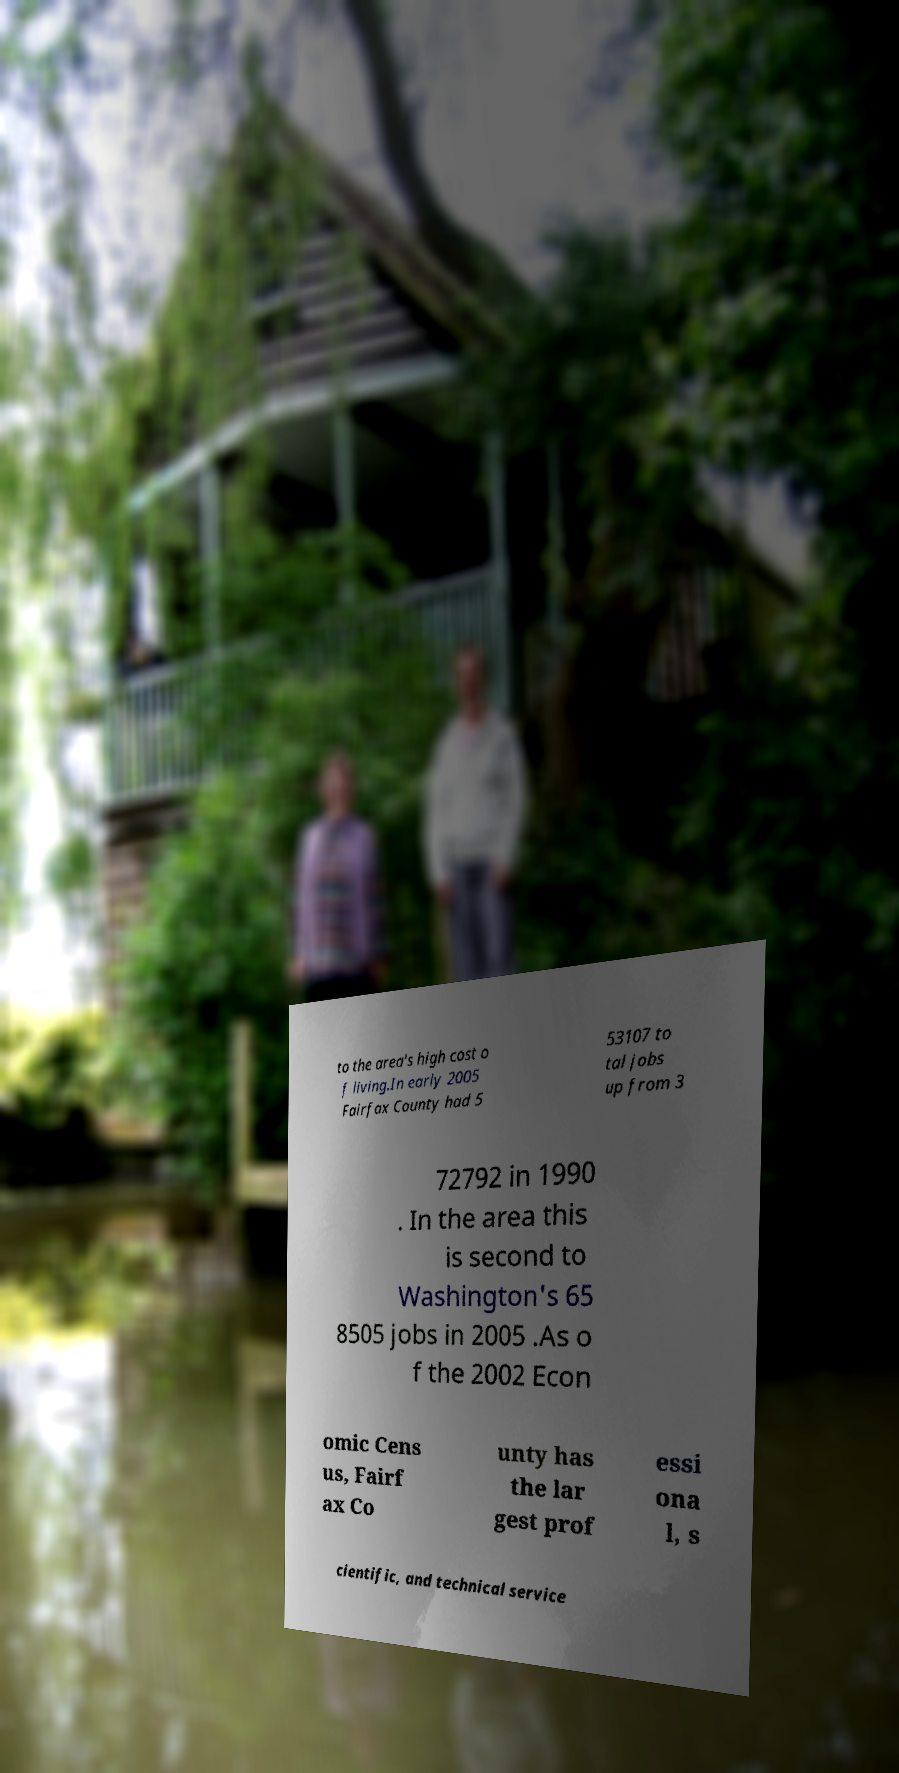Please read and relay the text visible in this image. What does it say? to the area's high cost o f living.In early 2005 Fairfax County had 5 53107 to tal jobs up from 3 72792 in 1990 . In the area this is second to Washington's 65 8505 jobs in 2005 .As o f the 2002 Econ omic Cens us, Fairf ax Co unty has the lar gest prof essi ona l, s cientific, and technical service 